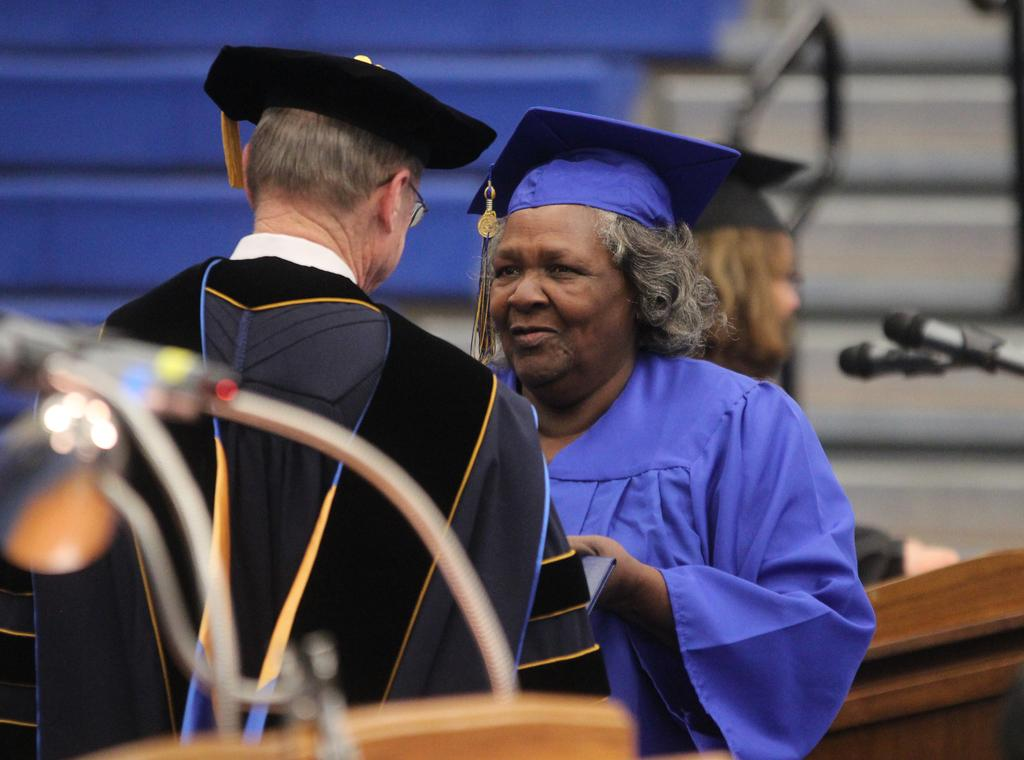How many people are in the image? There are two persons standing in the image. What is the appearance of one of the persons? One of the persons is wearing a graduation dress. What object can be seen near the persons? There is a podium in the image. What is the woman near the podium doing? The woman is standing near the podium. What device is present for amplifying sound? There is a microphone in the image. What architectural feature is visible in the background? There is a staircase in the image. How many cows are grazing on the staircase in the image? There are no cows present in the image, and therefore no cows are grazing on the staircase. What type of pipe can be seen near the microphone in the image? There is no pipe visible in the image; only a microphone is present. 